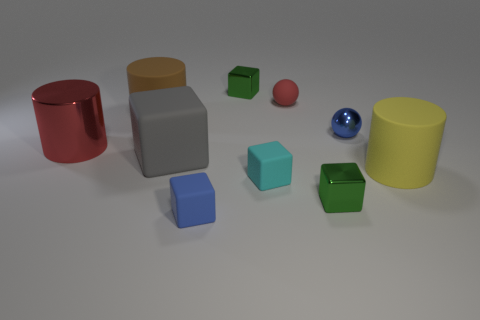There is another matte object that is the same shape as the yellow rubber object; what color is it?
Your answer should be compact. Brown. What is the size of the blue metallic object that is the same shape as the red matte object?
Ensure brevity in your answer.  Small. There is a small green block behind the brown cylinder; what material is it?
Provide a short and direct response. Metal. Are there fewer tiny green shiny cubes that are in front of the big gray rubber thing than tiny brown cylinders?
Your answer should be compact. No. The big matte thing that is right of the blue object in front of the yellow matte thing is what shape?
Make the answer very short. Cylinder. What color is the big block?
Provide a short and direct response. Gray. How many other objects are the same size as the yellow rubber cylinder?
Your response must be concise. 3. The thing that is behind the metal ball and left of the big gray thing is made of what material?
Provide a succinct answer. Rubber. There is a green cube in front of the blue sphere; does it have the same size as the large red shiny thing?
Give a very brief answer. No. Is the big metallic cylinder the same color as the tiny matte ball?
Make the answer very short. Yes. 